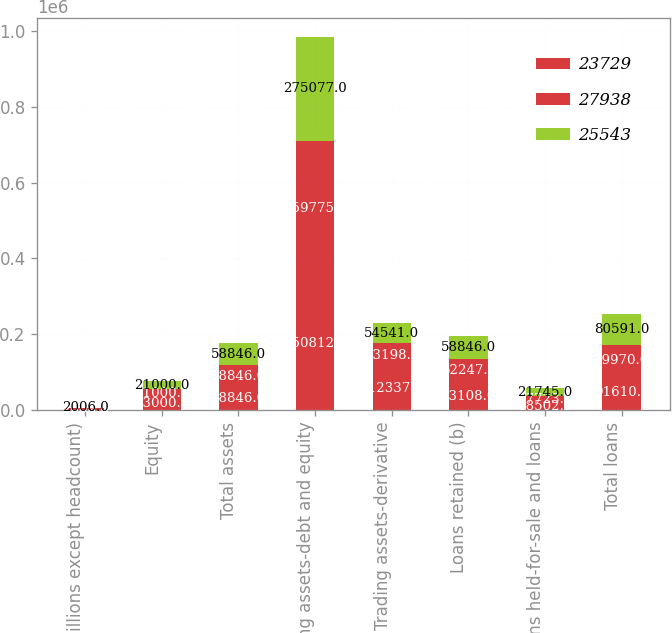Convert chart to OTSL. <chart><loc_0><loc_0><loc_500><loc_500><stacked_bar_chart><ecel><fcel>(in millions except headcount)<fcel>Equity<fcel>Total assets<fcel>Trading assets-debt and equity<fcel>Trading assets-derivative<fcel>Loans retained (b)<fcel>Loans held-for-sale and loans<fcel>Total loans<nl><fcel>23729<fcel>2008<fcel>33000<fcel>58846<fcel>350812<fcel>112337<fcel>73108<fcel>18502<fcel>91610<nl><fcel>27938<fcel>2007<fcel>21000<fcel>58846<fcel>359775<fcel>63198<fcel>62247<fcel>17723<fcel>79970<nl><fcel>25543<fcel>2006<fcel>21000<fcel>58846<fcel>275077<fcel>54541<fcel>58846<fcel>21745<fcel>80591<nl></chart> 